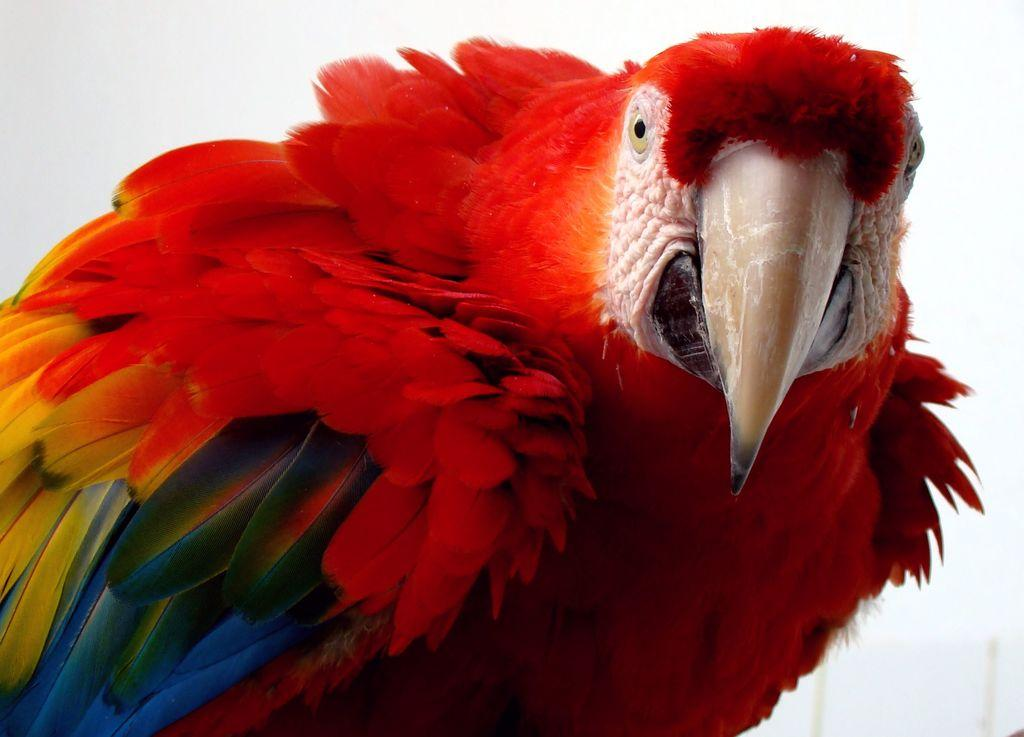What type of animal is present in the image? There is a bird in the image. Can you describe the bird's appearance? The bird has colorful feathers. What can be seen in the background of the image? The sky is visible in the background of the image. Is there a yoke visible in the image? No, there is no yoke present in the image. Can you tell me how the bird's memory is being tested in the image? There is no indication in the image that the bird's memory is being tested, as the image only shows a bird with colorful feathers against a sky background. 